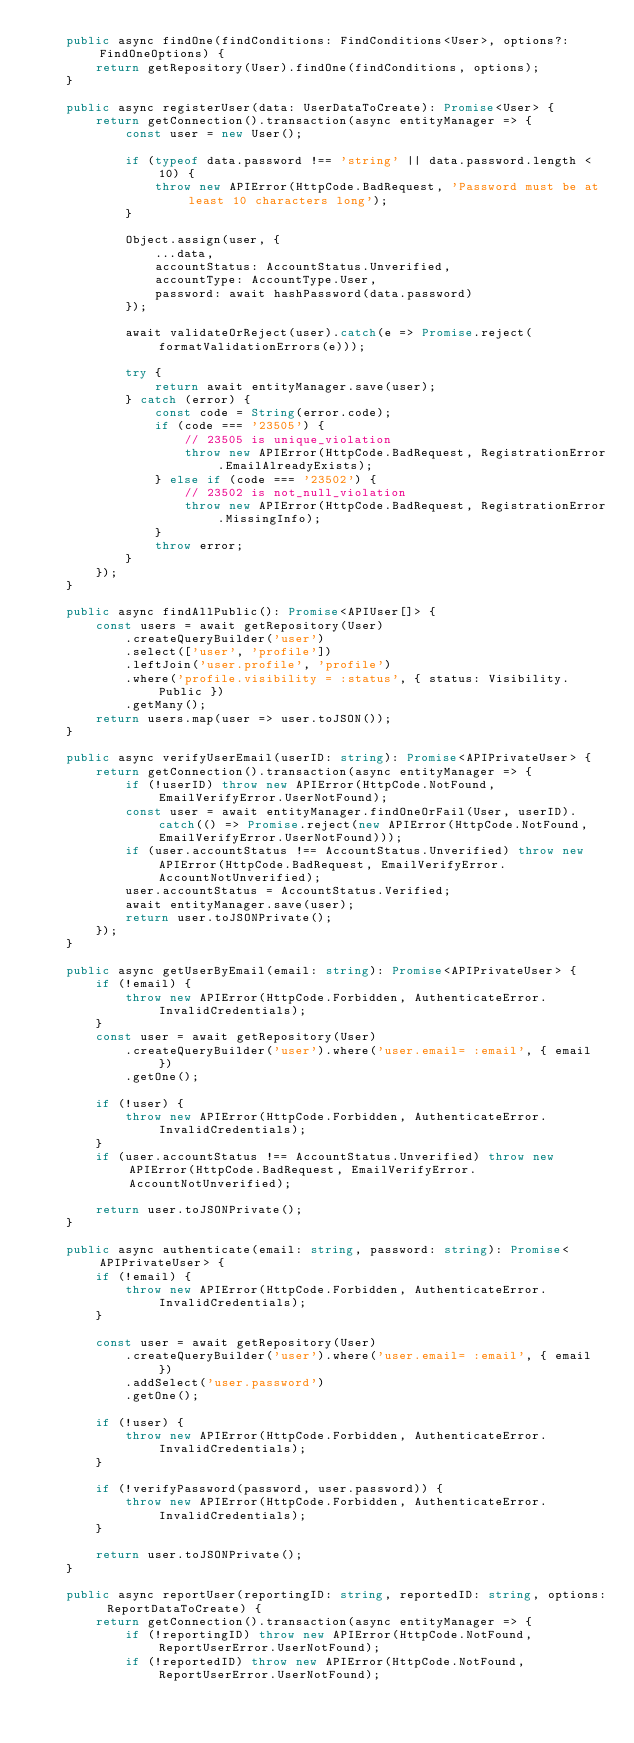<code> <loc_0><loc_0><loc_500><loc_500><_TypeScript_>	public async findOne(findConditions: FindConditions<User>, options?: FindOneOptions) {
		return getRepository(User).findOne(findConditions, options);
	}

	public async registerUser(data: UserDataToCreate): Promise<User> {
		return getConnection().transaction(async entityManager => {
			const user = new User();

			if (typeof data.password !== 'string' || data.password.length < 10) {
				throw new APIError(HttpCode.BadRequest, 'Password must be at least 10 characters long');
			}

			Object.assign(user, {
				...data,
				accountStatus: AccountStatus.Unverified,
				accountType: AccountType.User,
				password: await hashPassword(data.password)
			});

			await validateOrReject(user).catch(e => Promise.reject(formatValidationErrors(e)));

			try {
				return await entityManager.save(user);
			} catch (error) {
				const code = String(error.code);
				if (code === '23505') {
					// 23505 is unique_violation
					throw new APIError(HttpCode.BadRequest, RegistrationError.EmailAlreadyExists);
				} else if (code === '23502') {
					// 23502 is not_null_violation
					throw new APIError(HttpCode.BadRequest, RegistrationError.MissingInfo);
				}
				throw error;
			}
		});
	}

	public async findAllPublic(): Promise<APIUser[]> {
		const users = await getRepository(User)
			.createQueryBuilder('user')
			.select(['user', 'profile'])
			.leftJoin('user.profile', 'profile')
			.where('profile.visibility = :status', { status: Visibility.Public })
			.getMany();
		return users.map(user => user.toJSON());
	}

	public async verifyUserEmail(userID: string): Promise<APIPrivateUser> {
		return getConnection().transaction(async entityManager => {
			if (!userID) throw new APIError(HttpCode.NotFound, EmailVerifyError.UserNotFound);
			const user = await entityManager.findOneOrFail(User, userID).catch(() => Promise.reject(new APIError(HttpCode.NotFound, EmailVerifyError.UserNotFound)));
			if (user.accountStatus !== AccountStatus.Unverified) throw new APIError(HttpCode.BadRequest, EmailVerifyError.AccountNotUnverified);
			user.accountStatus = AccountStatus.Verified;
			await entityManager.save(user);
			return user.toJSONPrivate();
		});
	}

	public async getUserByEmail(email: string): Promise<APIPrivateUser> {
		if (!email) {
			throw new APIError(HttpCode.Forbidden, AuthenticateError.InvalidCredentials);
		}
		const user = await getRepository(User)
			.createQueryBuilder('user').where('user.email= :email', { email })
			.getOne();

		if (!user) {
			throw new APIError(HttpCode.Forbidden, AuthenticateError.InvalidCredentials);
		}
		if (user.accountStatus !== AccountStatus.Unverified) throw new APIError(HttpCode.BadRequest, EmailVerifyError.AccountNotUnverified);

		return user.toJSONPrivate();
	}

	public async authenticate(email: string, password: string): Promise<APIPrivateUser> {
		if (!email) {
			throw new APIError(HttpCode.Forbidden, AuthenticateError.InvalidCredentials);
		}

		const user = await getRepository(User)
			.createQueryBuilder('user').where('user.email= :email', { email })
			.addSelect('user.password')
			.getOne();

		if (!user) {
			throw new APIError(HttpCode.Forbidden, AuthenticateError.InvalidCredentials);
		}

		if (!verifyPassword(password, user.password)) {
			throw new APIError(HttpCode.Forbidden, AuthenticateError.InvalidCredentials);
		}

		return user.toJSONPrivate();
	}

	public async reportUser(reportingID: string, reportedID: string, options: ReportDataToCreate) {
		return getConnection().transaction(async entityManager => {
			if (!reportingID) throw new APIError(HttpCode.NotFound, ReportUserError.UserNotFound);
			if (!reportedID) throw new APIError(HttpCode.NotFound, ReportUserError.UserNotFound);</code> 